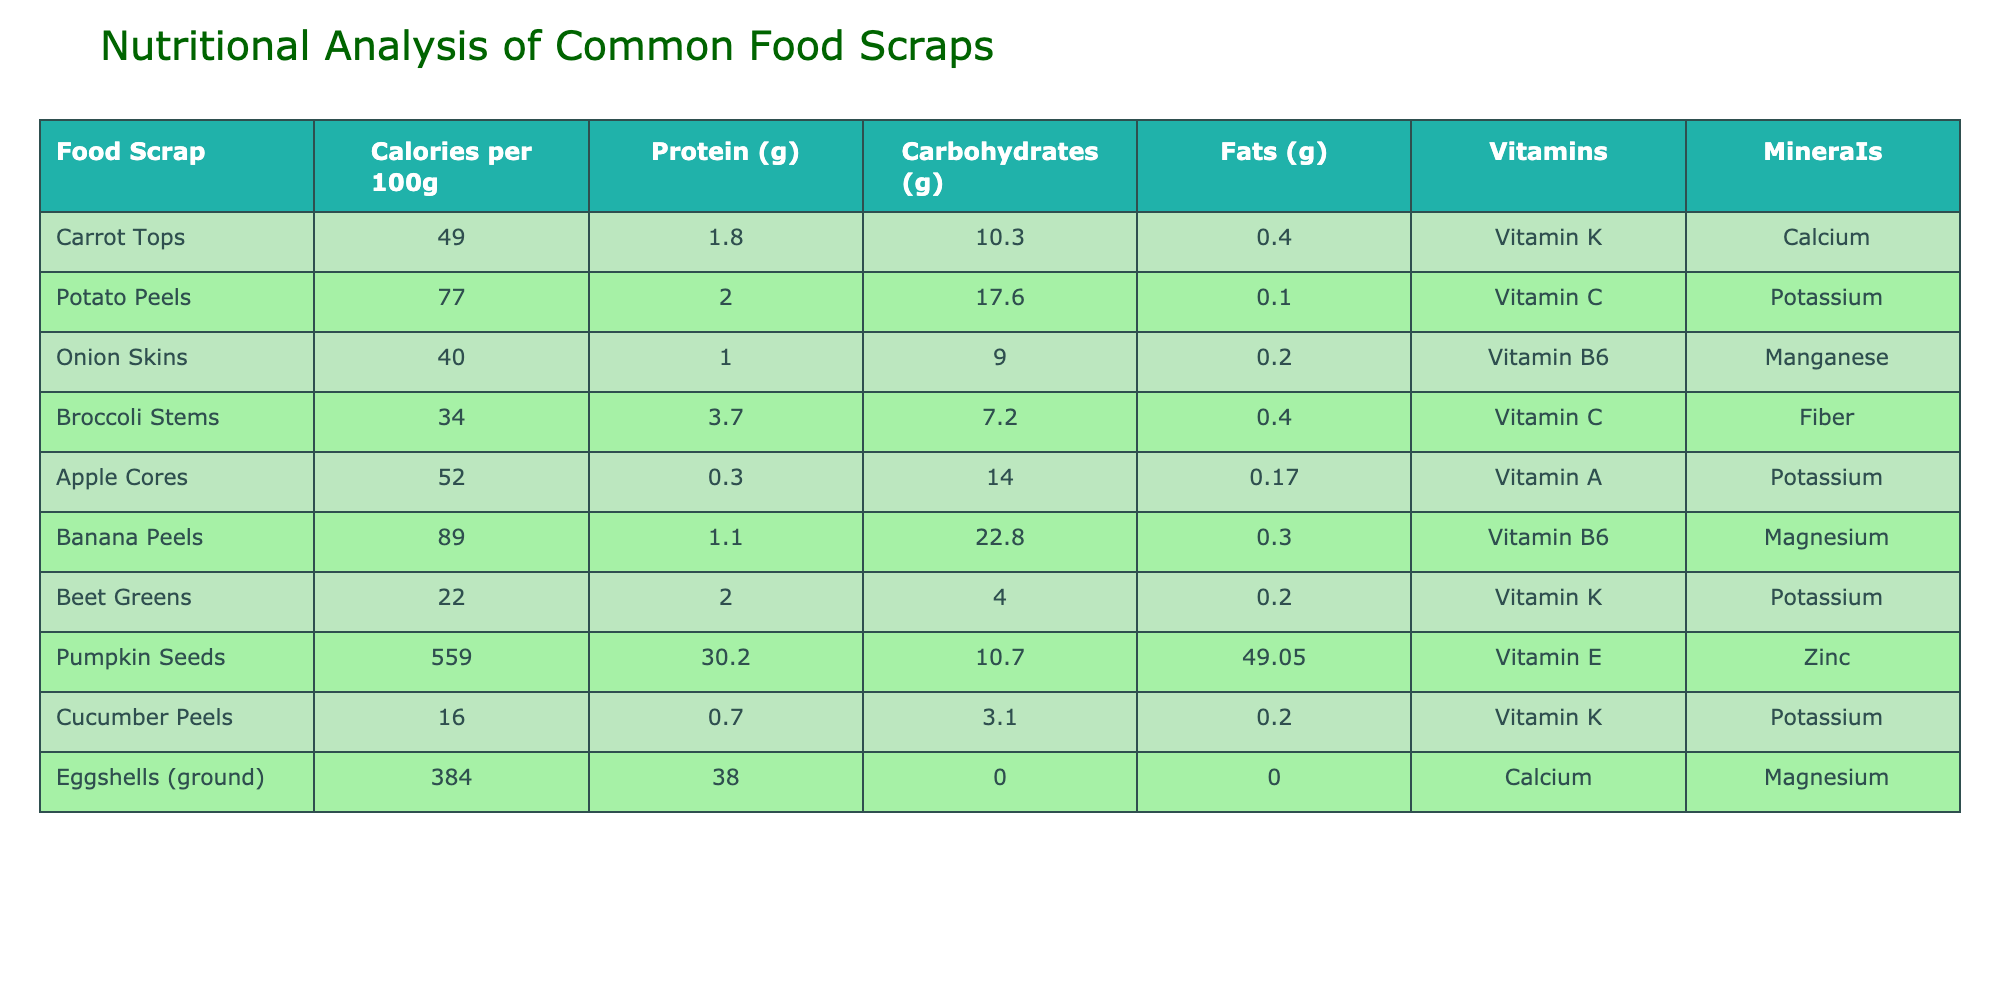What food scrap has the highest protein content per 100g? By reviewing the "Protein (g)" column, we find that eggshells (ground) have the highest protein content at 38.0g per 100g.
Answer: Eggshells (ground) Which food scrap contains the least calories per 100g? Looking at the "Calories per 100g" column, cucumber peels have the least calories at 16 per 100g.
Answer: Cucumber Peels What is the total carbohydrate content from pumpkin seeds and potato peels? From the "Carbohydrates (g)" column, pumpkin seeds have 10.7g and potato peels have 17.6g. Adding these together gives 10.7 + 17.6 = 28.3g of carbohydrates.
Answer: 28.3g Is it true that apple cores contain more carbohydrates than broccoli stems? From the table, apple cores have 14.0g and broccoli stems have 7.2g of carbohydrates. Since 14.0 > 7.2, the statement is true.
Answer: Yes What percentage of the total calorie content do carrot tops contribute when combined with beet greens? Carrot tops have 49 calories and beet greens have 22 calories, summing to 49 + 22 = 71 calories. The percentage contribution of carrot tops is (49/71) * 100 ≈ 69.0%.
Answer: 69.0% Which vitamin is most frequently present in the listed food scraps? Reviewing the "Vitamins" column, vitamin K appears in both carrot tops and cucumber peels, vitamin C is in potato peels and broccoli stems, vitamin A in apple cores, and so on. After counting occurrences, vitamin K appears most often, with 3 occurrences.
Answer: Vitamin K What is the average fat content of the food scraps listed? To find the average fat content, we sum the fat amounts: 0.4 + 0.1 + 0.2 + 0.4 + 0.17 + 0.3 + 0.2 + 49.05 + 0.2 + 0 = 50.57g. There are 10 food scraps, so the average is 50.57/10 = 5.057g.
Answer: 5.057g Do potato peels contain more potassium than banana peels? Based on the mineral information, both foods list potassium as a mineral, but the potassium content is not explicitly given in the table. Therefore, the question cannot be evaluated directly as "yes" or "no."
Answer: Cannot determine How much higher is the calorie content of banana peels compared to broccoli stems? The calorie content of banana peels is 89 and that of broccoli stems is 34. The difference in calorie content is 89 - 34 = 55 calories.
Answer: 55 calories 